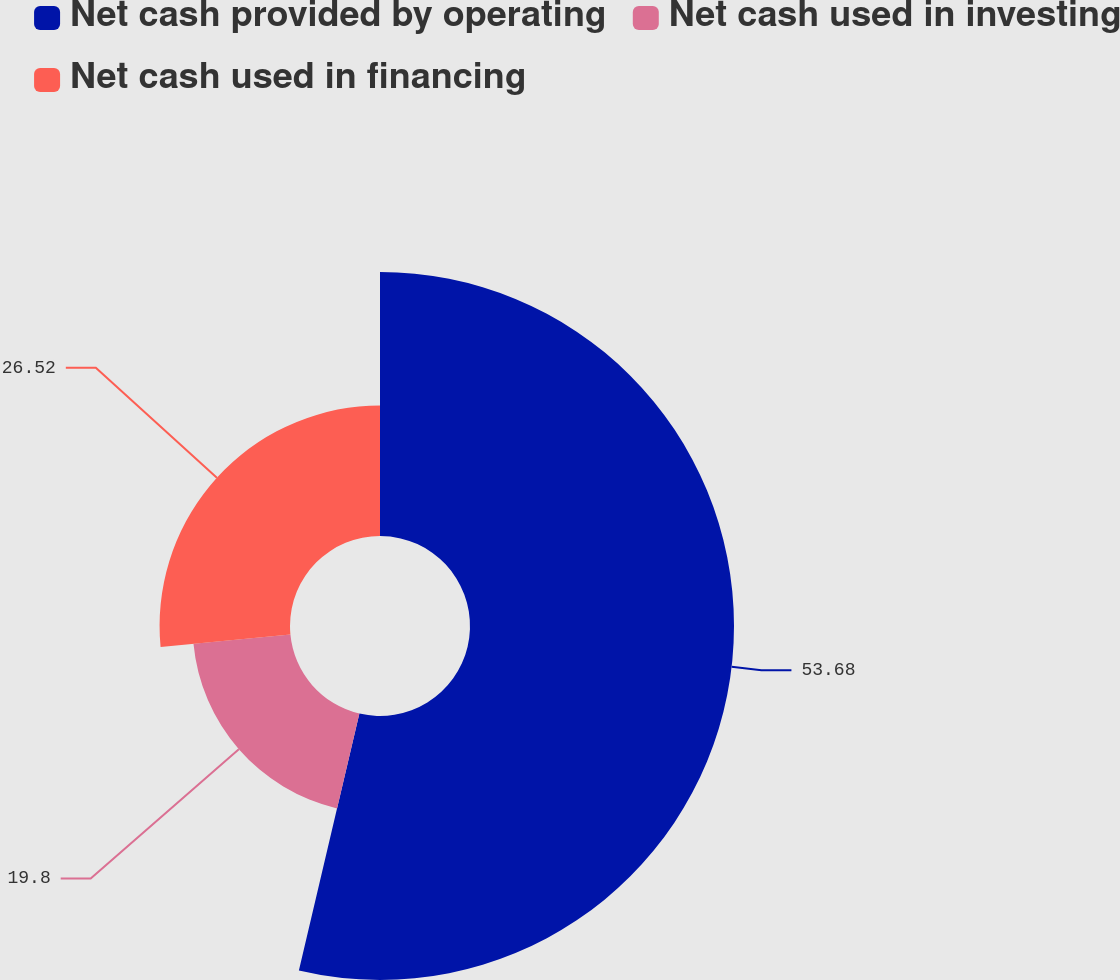Convert chart to OTSL. <chart><loc_0><loc_0><loc_500><loc_500><pie_chart><fcel>Net cash provided by operating<fcel>Net cash used in investing<fcel>Net cash used in financing<nl><fcel>53.68%<fcel>19.8%<fcel>26.52%<nl></chart> 